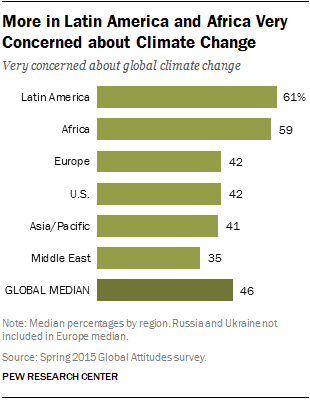Outline some significant characteristics in this image. According to a recent survey, 59% of Africans are highly concerned about global climate change, reflecting a growing awareness of the urgent need for action to mitigate its impact. Of the countries, only two share similar values. 